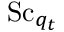<formula> <loc_0><loc_0><loc_500><loc_500>S c _ { q _ { t } }</formula> 